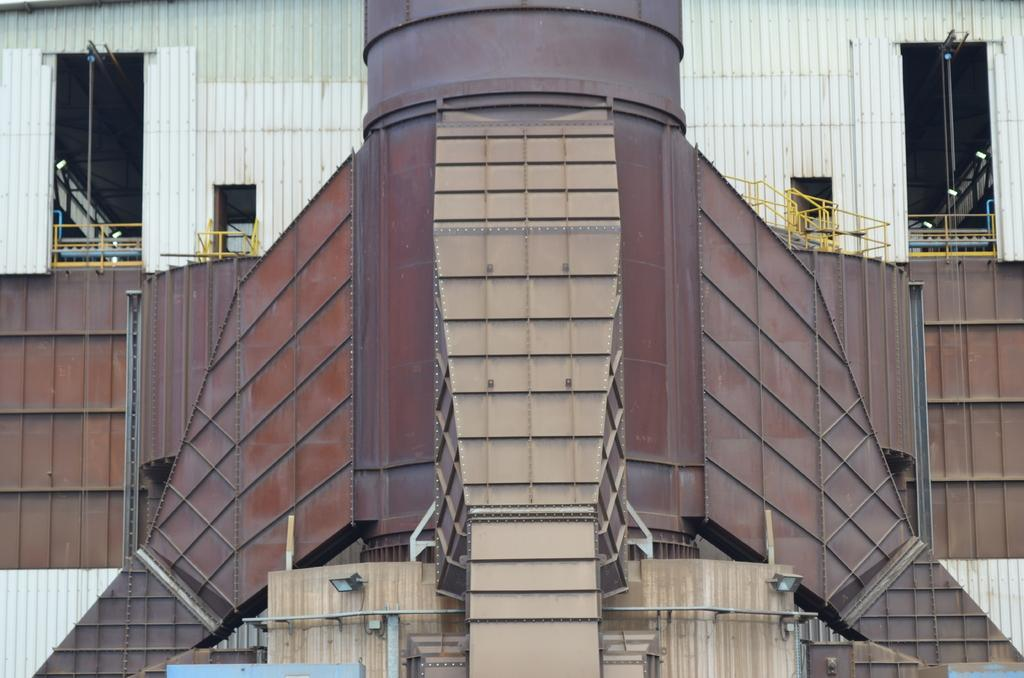What type of building is shown in the image? There is a commercial building in the image. What time of day is it in the image, and how does the thread interact with the dust? The provided facts do not mention the time of day or the presence of thread or dust in the image. Therefore, we cannot answer these questions based on the given information. 